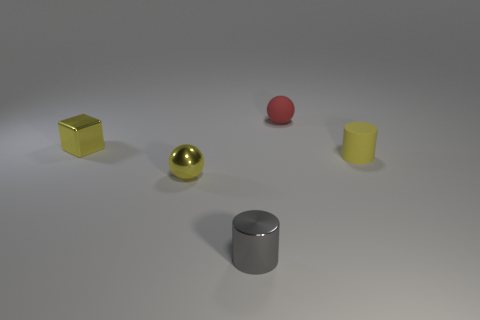Add 1 small gray metallic objects. How many objects exist? 6 Subtract all cylinders. How many objects are left? 3 Add 3 tiny gray cylinders. How many tiny gray cylinders exist? 4 Subtract 0 brown cylinders. How many objects are left? 5 Subtract all small yellow metal spheres. Subtract all small gray shiny cylinders. How many objects are left? 3 Add 4 small red rubber balls. How many small red rubber balls are left? 5 